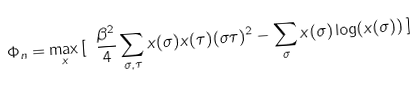<formula> <loc_0><loc_0><loc_500><loc_500>\Phi _ { n } = \max _ { x } \, [ \ \frac { \beta ^ { 2 } } { 4 } \sum _ { \sigma , \tau } x ( \sigma ) x ( \tau ) ( \sigma \tau ) ^ { 2 } - \sum _ { \sigma } x ( \sigma ) \log ( x ( \sigma ) ) \, ]</formula> 